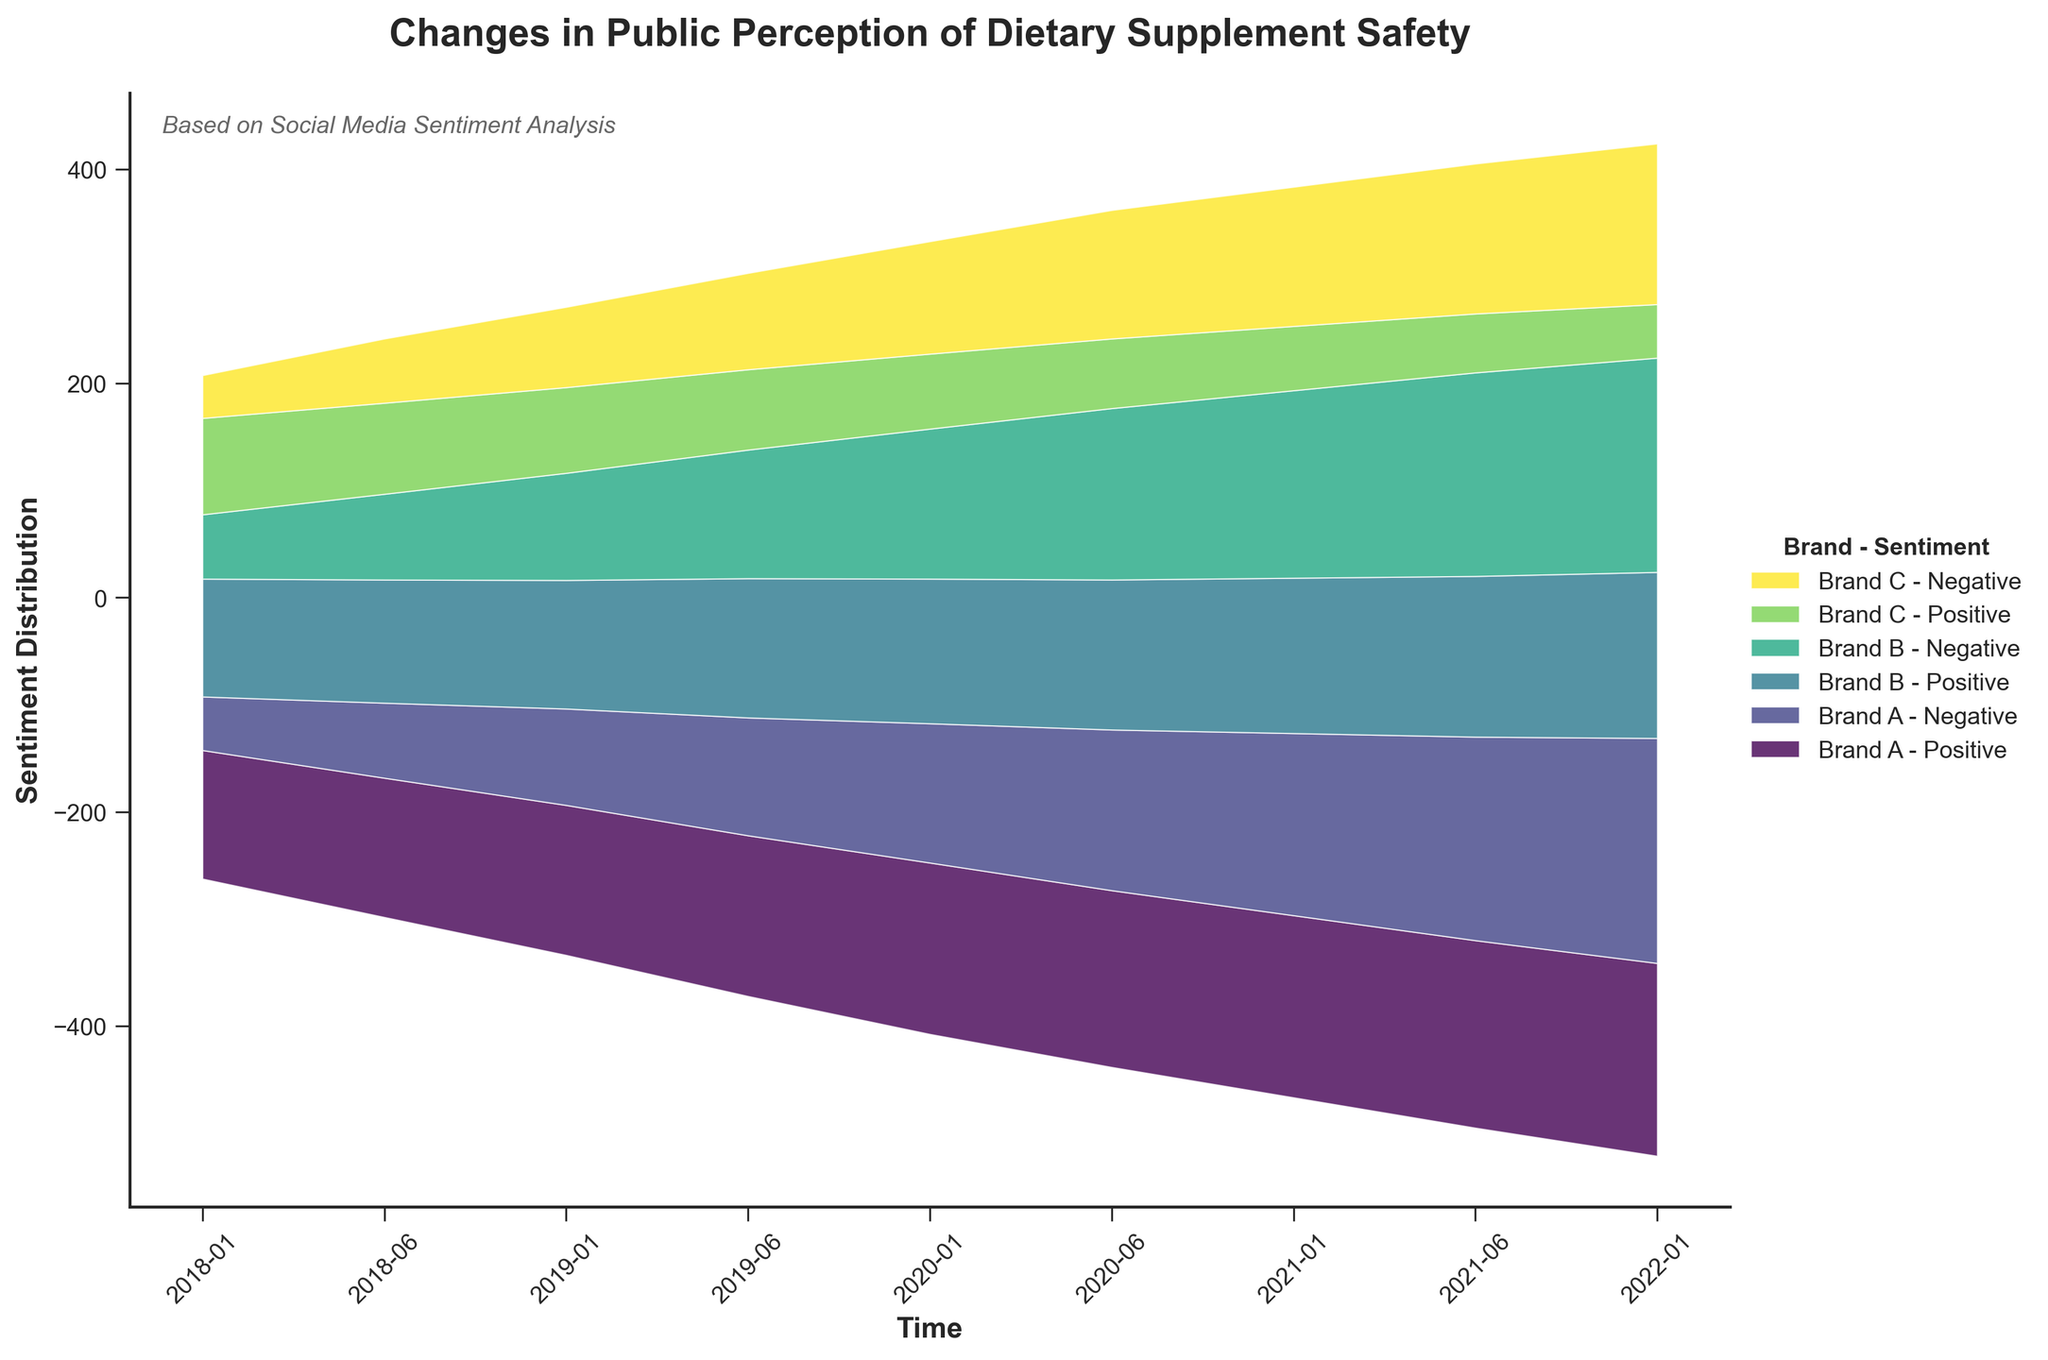How many brands are represented in the graph? By observing the labels in the legend, we can see three distinct brands mentioned.
Answer: Three What's the general trend in the sentiment for Brand A from 2018 to 2022? The stream graph shows the positive sentiment for Brand A gradually increasing with time, while the negative sentiment also rises. Both sentiments increase, but the negative sentiment shows a steeper rise towards the end.
Answer: Both sentiments increase, stronger rise in negative Which brand has the highest negative sentiment in 2022? Looking at the stream graph towards the end of 2022, Brand A's negative sentiment reaches the highest value compared to Brands B and C.
Answer: Brand A What is the sentiment distribution trend for Brand C over time? Examining the data layer corresponding to Brand C, the positive sentiment gradually decreases, and the negative sentiment increases over the years.
Answer: Positive decreases, negative increases Between Brand B and Brand C, which shows a more significant increase in negative sentiment from 2018 to 2022? By comparing the thickness of the negative sentiment layers from the beginning to the end of the timeline, it becomes evident that Brand B's negative sentiment has a more substantial increase compared to Brand C.
Answer: Brand B How do the trends in positive sentiment for Brand B compare to those of Brand A? While both brands show increasing positive sentiment over time, Brand A consistently has a higher positive sentiment than Brand B, and the gap widens as time progresses.
Answer: Both increase, Brand A is higher Which year shows a significant rise in negative sentiment for all three brands? Observing the stack's thickness, 2020 shows a noticeable increase in negative sentiment for all three brands.
Answer: 2020 What can you infer about public perception of dietary supplement safety from 2020 to 2022? From 2020 to 2022, the graph indicates a notable increase in negative sentiment for all brands, suggesting growing concerns about dietary supplement safety during this period.
Answer: Increasing concerns Which brand shows a close balance between positive and negative sentiments by 2021? Brand A, in 2021, has similar heights for both positive and negative sentiments, indicating a balanced perception.
Answer: Brand A Is there a brand that sees a consistent decline in positive sentiment across the timeline? Yes, Brand C shows a consistently decreasing trend in positive sentiment from 2018 to 2022, as seen by the thinning of its positive sentiment layer.
Answer: Brand C 